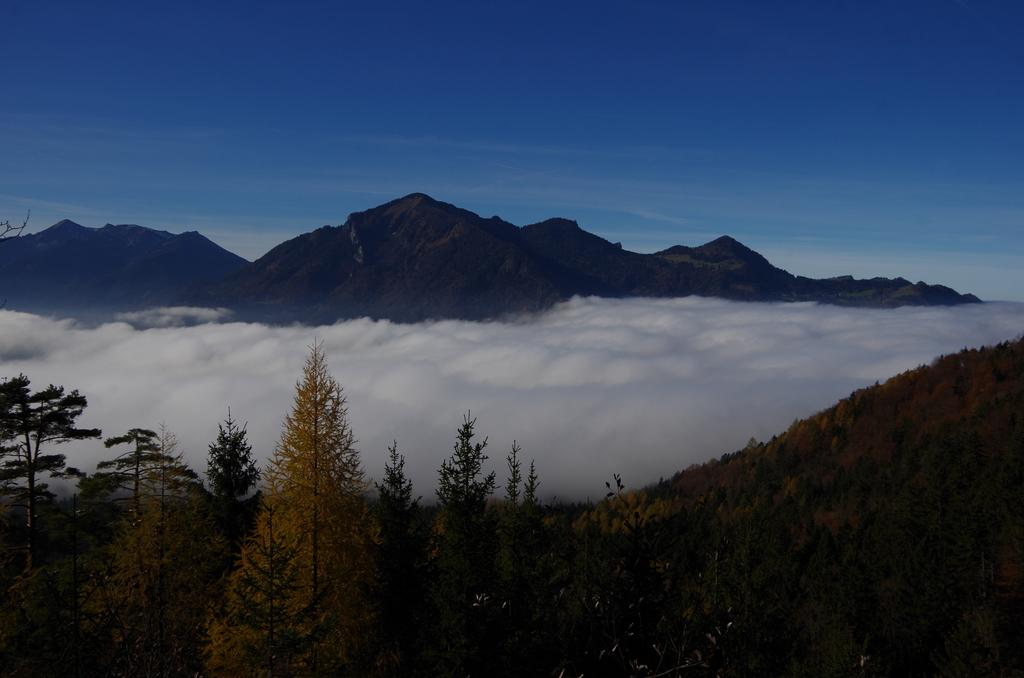What type of vegetation is at the bottom of the image? There are trees at the bottom of the image. What geographical features are in the middle of the image? There are hills in the middle of the image. What is visible at the top of the image? The sky is visible at the top of the image. Where is the cellar located in the image? There is no cellar present in the image. What type of cord is used to connect the hills in the image? There is no cord connecting the hills in the image; they are separate geographical features. 